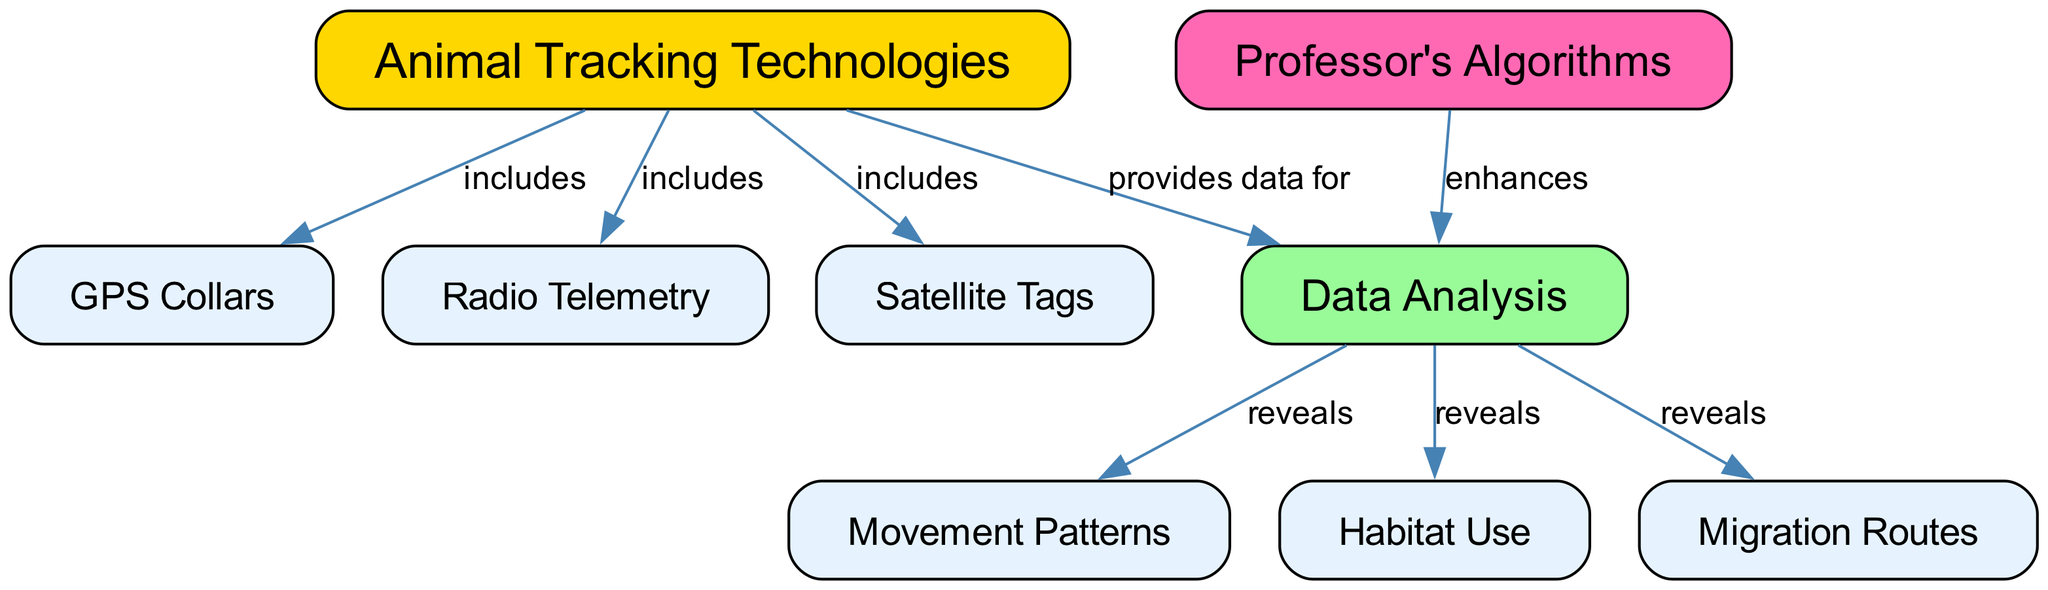What are the three types of animal tracking technologies mentioned in the concept map? The diagram lists three types of animal tracking technologies: GPS collars, Radio Telemetry, and Satellite Tags. These are labeled under the "Animal Tracking Technologies" node and connected with edges marked as "includes."
Answer: GPS Collars, Radio Telemetry, Satellite Tags How many nodes are there in the diagram? Counting the nodes in the diagram, there are eight distinct nodes that represent different concepts related to animal tracking technologies and their applications.
Answer: 8 What type of analysis do the professor's algorithms enhance? The edges indicate that the professor's algorithms enhance the data analysis that follows the tracking technologies. The connection labeled "enhances" links these two nodes, showing a clear relationship.
Answer: Data Analysis Which application reveals migration routes? The diagram shows that the data analysis contributes to revealing several applications, including migration routes, as indicated by the edge from the data analysis node to the migration routes node marked as "reveals."
Answer: Migration Routes What relationship exists between data analysis and animal tracking technologies? The edge from the "Animal Tracking Technologies" node to the "Data Analysis" node is labeled "provides data for," indicating that the tracking technologies supply information that enables data analysis.
Answer: provides data for How many applications are revealed through data analysis? The diagram specifies that data analysis reveals three applications: movement patterns, habitat use, and migration routes. Counting these applications shows the scope of data interpretation in wildlife biology.
Answer: 3 Which tracking technology is represented by GPS collars? GPS collars are explicitly listed as one of the three technologies included under the "Animal Tracking Technologies" node. This direct connection indicates its classification within the broader category.
Answer: GPS Collars What does the data analysis reveal about animal movements? The diagram shows that data analysis reveals important information regarding movement patterns, which is specifically connected to the data analysis node by an edge labeled "reveals."
Answer: Movement Patterns 